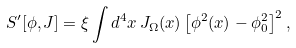<formula> <loc_0><loc_0><loc_500><loc_500>S ^ { \prime } [ \phi , J ] = \xi \int d ^ { 4 } x \, J _ { \Omega } ( x ) \left [ \phi ^ { 2 } ( x ) - \phi _ { 0 } ^ { 2 } \right ] ^ { 2 } ,</formula> 